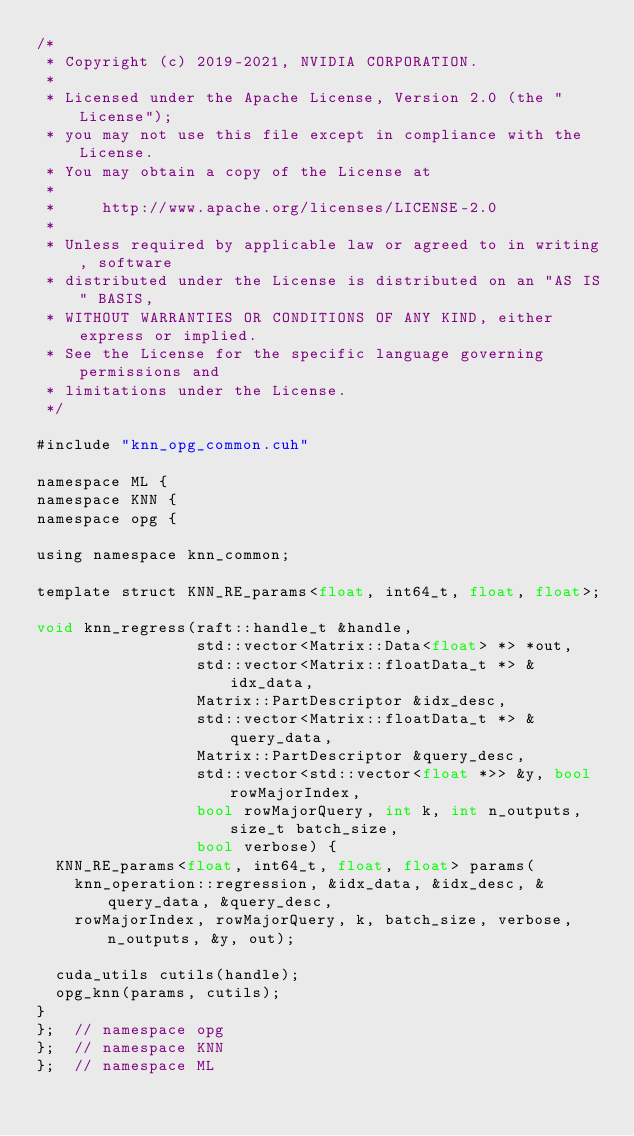<code> <loc_0><loc_0><loc_500><loc_500><_Cuda_>/*
 * Copyright (c) 2019-2021, NVIDIA CORPORATION.
 *
 * Licensed under the Apache License, Version 2.0 (the "License");
 * you may not use this file except in compliance with the License.
 * You may obtain a copy of the License at
 *
 *     http://www.apache.org/licenses/LICENSE-2.0
 *
 * Unless required by applicable law or agreed to in writing, software
 * distributed under the License is distributed on an "AS IS" BASIS,
 * WITHOUT WARRANTIES OR CONDITIONS OF ANY KIND, either express or implied.
 * See the License for the specific language governing permissions and
 * limitations under the License.
 */

#include "knn_opg_common.cuh"

namespace ML {
namespace KNN {
namespace opg {

using namespace knn_common;

template struct KNN_RE_params<float, int64_t, float, float>;

void knn_regress(raft::handle_t &handle,
                 std::vector<Matrix::Data<float> *> *out,
                 std::vector<Matrix::floatData_t *> &idx_data,
                 Matrix::PartDescriptor &idx_desc,
                 std::vector<Matrix::floatData_t *> &query_data,
                 Matrix::PartDescriptor &query_desc,
                 std::vector<std::vector<float *>> &y, bool rowMajorIndex,
                 bool rowMajorQuery, int k, int n_outputs, size_t batch_size,
                 bool verbose) {
  KNN_RE_params<float, int64_t, float, float> params(
    knn_operation::regression, &idx_data, &idx_desc, &query_data, &query_desc,
    rowMajorIndex, rowMajorQuery, k, batch_size, verbose, n_outputs, &y, out);

  cuda_utils cutils(handle);
  opg_knn(params, cutils);
}
};  // namespace opg
};  // namespace KNN
};  // namespace ML
</code> 